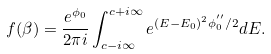<formula> <loc_0><loc_0><loc_500><loc_500>f ( \beta ) = \frac { e ^ { \phi _ { 0 } } } { 2 \pi i } \int ^ { c + i \infty } _ { c - i \infty } e ^ { ( E - E _ { 0 } ) ^ { 2 } \phi _ { 0 } ^ { ^ { \prime \prime } } / 2 } d E .</formula> 